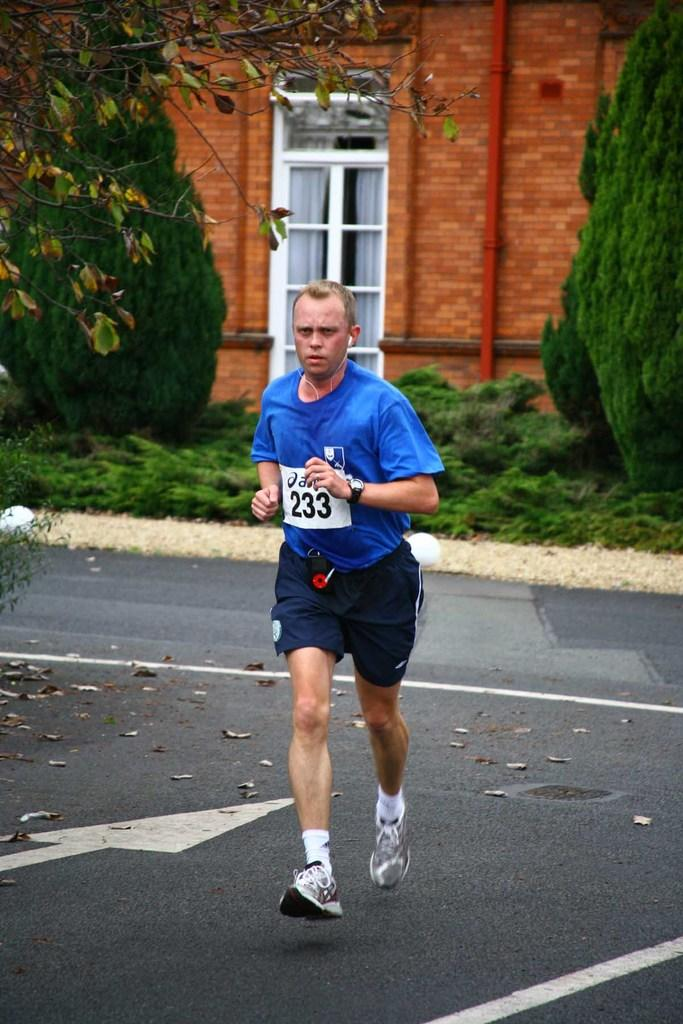Provide a one-sentence caption for the provided image. A man running in a roadway with the number 233 on his blue tshirt. 